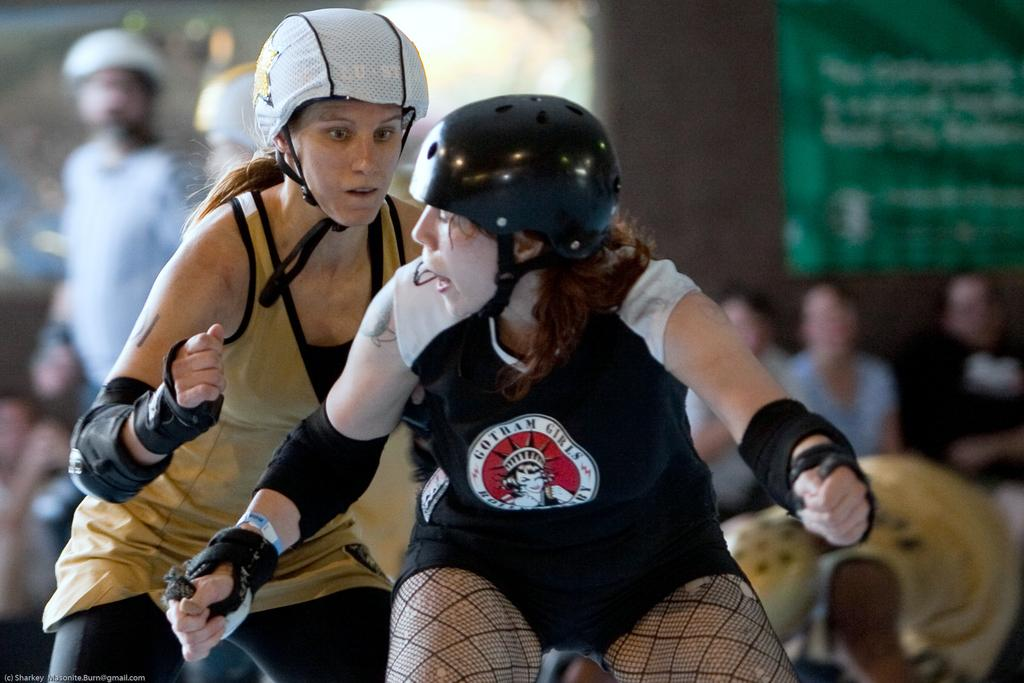How many people are in the image? There are people in the image. Can you describe any specific features of the people? Two of the people are wearing helmets. What can be observed about the background of the image? The background of the image is blurry. What type of harmony is being played by the maid in the image? There is no maid or any musical instrument present in the image, so it is not possible to determine if any harmony is being played. 